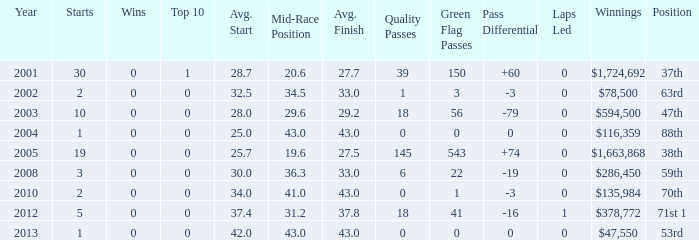What is the average top 10 score for 2 starts, winnings of $135,984 and an average finish more than 43? None. 